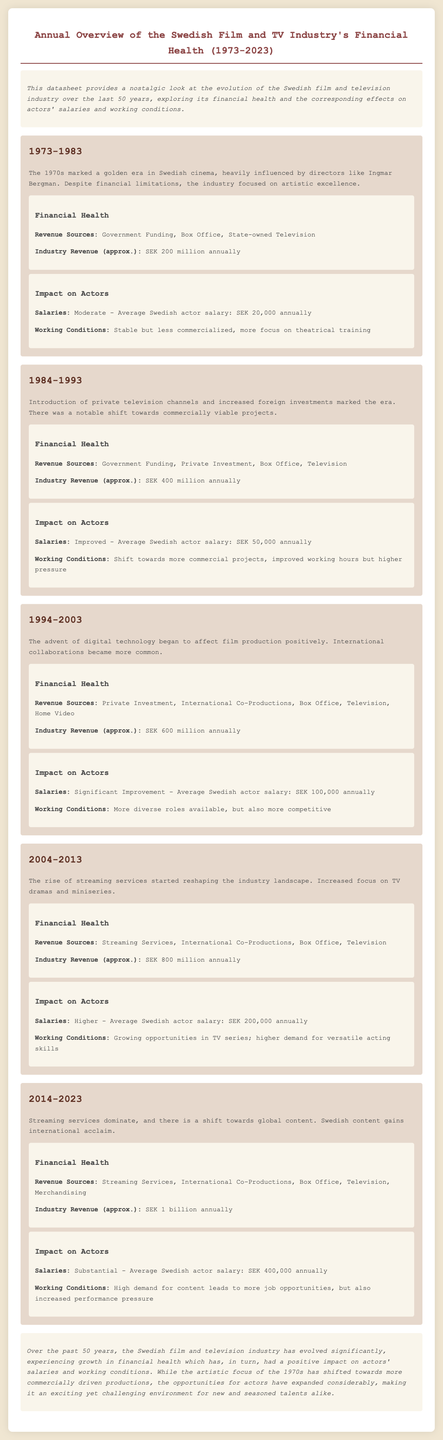what was the average salary of actors in 1973-1983? The document states that the average Swedish actor salary during this period was SEK 20,000 annually.
Answer: SEK 20,000 how much was the industry revenue in 1994-2003? The document indicates that the industry revenue in this period was approximately SEK 600 million annually.
Answer: SEK 600 million what did the revenue sources include in 2004-2013? The revenue sources listed for this period are Streaming Services, International Co-Productions, Box Office, and Television.
Answer: Streaming Services, International Co-Productions, Box Office, Television what is the trend in actor salaries from 1984-1993 to 2014-2023? The progression of salaries shows an increase from SEK 50,000 in 1984-1993 to SEK 400,000 in 2014-2023, indicating a substantial improvement over the decades.
Answer: Increase how did working conditions change from 1973-1983 to 2004-2013? The document explains that working conditions evolved from stable and less commercialized in 1973-1983 to opportunities growing in TV series and higher demand for versatile acting skills in 2004-2013.
Answer: Improved with more opportunities what is the main focus of the Swedish film industry in the 1970s? According to the document, the main focus during the 1970s was on artistic excellence.
Answer: Artistic excellence what was the estimated industry revenue in 2023? The document states that the estimated industry revenue for this year was approximately SEK 1 billion annually.
Answer: SEK 1 billion how did the introduction of private television channels affect actor salaries? The introduction led to improved salaries, as indicated by an increase from SEK 20,000 in 1973-1983 to SEK 50,000 in 1984-1993.
Answer: Improved salaries what type of document is this? This is an annual overview datasheet of the financial health of the Swedish film and TV industry.
Answer: Datasheet 